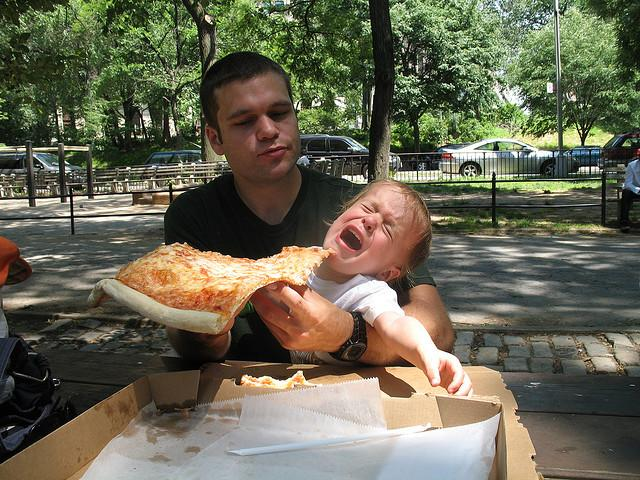What is the most popular pizza cheese? Please explain your reasoning. mozzarella. Mozzarella is used. 